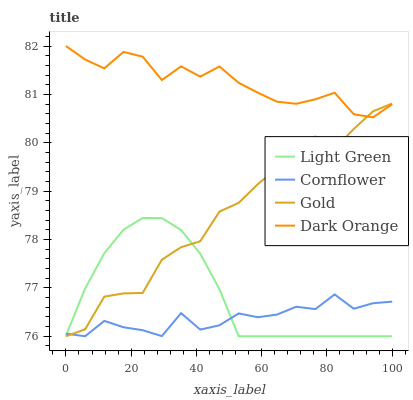Does Cornflower have the minimum area under the curve?
Answer yes or no. Yes. Does Dark Orange have the maximum area under the curve?
Answer yes or no. Yes. Does Gold have the minimum area under the curve?
Answer yes or no. No. Does Gold have the maximum area under the curve?
Answer yes or no. No. Is Light Green the smoothest?
Answer yes or no. Yes. Is Gold the roughest?
Answer yes or no. Yes. Is Gold the smoothest?
Answer yes or no. No. Is Light Green the roughest?
Answer yes or no. No. Does Cornflower have the lowest value?
Answer yes or no. Yes. Does Dark Orange have the lowest value?
Answer yes or no. No. Does Dark Orange have the highest value?
Answer yes or no. Yes. Does Gold have the highest value?
Answer yes or no. No. Is Cornflower less than Dark Orange?
Answer yes or no. Yes. Is Dark Orange greater than Light Green?
Answer yes or no. Yes. Does Gold intersect Cornflower?
Answer yes or no. Yes. Is Gold less than Cornflower?
Answer yes or no. No. Is Gold greater than Cornflower?
Answer yes or no. No. Does Cornflower intersect Dark Orange?
Answer yes or no. No. 